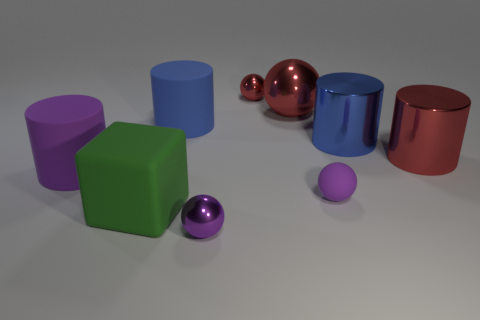Subtract all purple rubber cylinders. How many cylinders are left? 3 Subtract all cyan balls. How many blue cylinders are left? 2 Add 1 purple cylinders. How many objects exist? 10 Subtract all red balls. How many balls are left? 2 Subtract 1 balls. How many balls are left? 3 Subtract all brown spheres. Subtract all blue cylinders. How many spheres are left? 4 Subtract 0 cyan balls. How many objects are left? 9 Subtract all cubes. How many objects are left? 8 Subtract all tiny rubber spheres. Subtract all shiny cylinders. How many objects are left? 6 Add 5 big red shiny cylinders. How many big red shiny cylinders are left? 6 